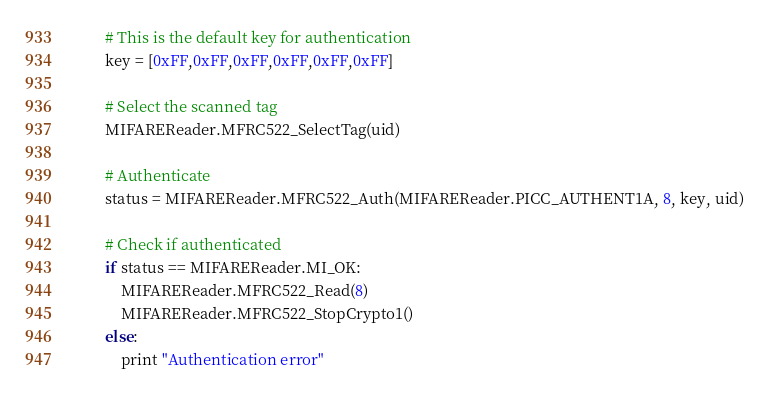<code> <loc_0><loc_0><loc_500><loc_500><_Python_>        # This is the default key for authentication
        key = [0xFF,0xFF,0xFF,0xFF,0xFF,0xFF]

        # Select the scanned tag
        MIFAREReader.MFRC522_SelectTag(uid)

        # Authenticate
        status = MIFAREReader.MFRC522_Auth(MIFAREReader.PICC_AUTHENT1A, 8, key, uid)

        # Check if authenticated
        if status == MIFAREReader.MI_OK:
            MIFAREReader.MFRC522_Read(8)
            MIFAREReader.MFRC522_StopCrypto1()
        else:
            print "Authentication error"
</code> 